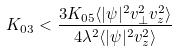<formula> <loc_0><loc_0><loc_500><loc_500>K _ { 0 3 } < \frac { 3 K _ { 0 5 } \langle | \psi | ^ { 2 } v _ { \perp } ^ { 2 } v _ { z } ^ { 2 } \rangle } { 4 \lambda ^ { 2 } \langle | \psi | ^ { 2 } v _ { z } ^ { 2 } \rangle }</formula> 